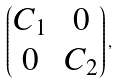<formula> <loc_0><loc_0><loc_500><loc_500>\begin{pmatrix} C _ { 1 } & 0 \\ 0 & C _ { 2 } \\ \end{pmatrix} ,</formula> 